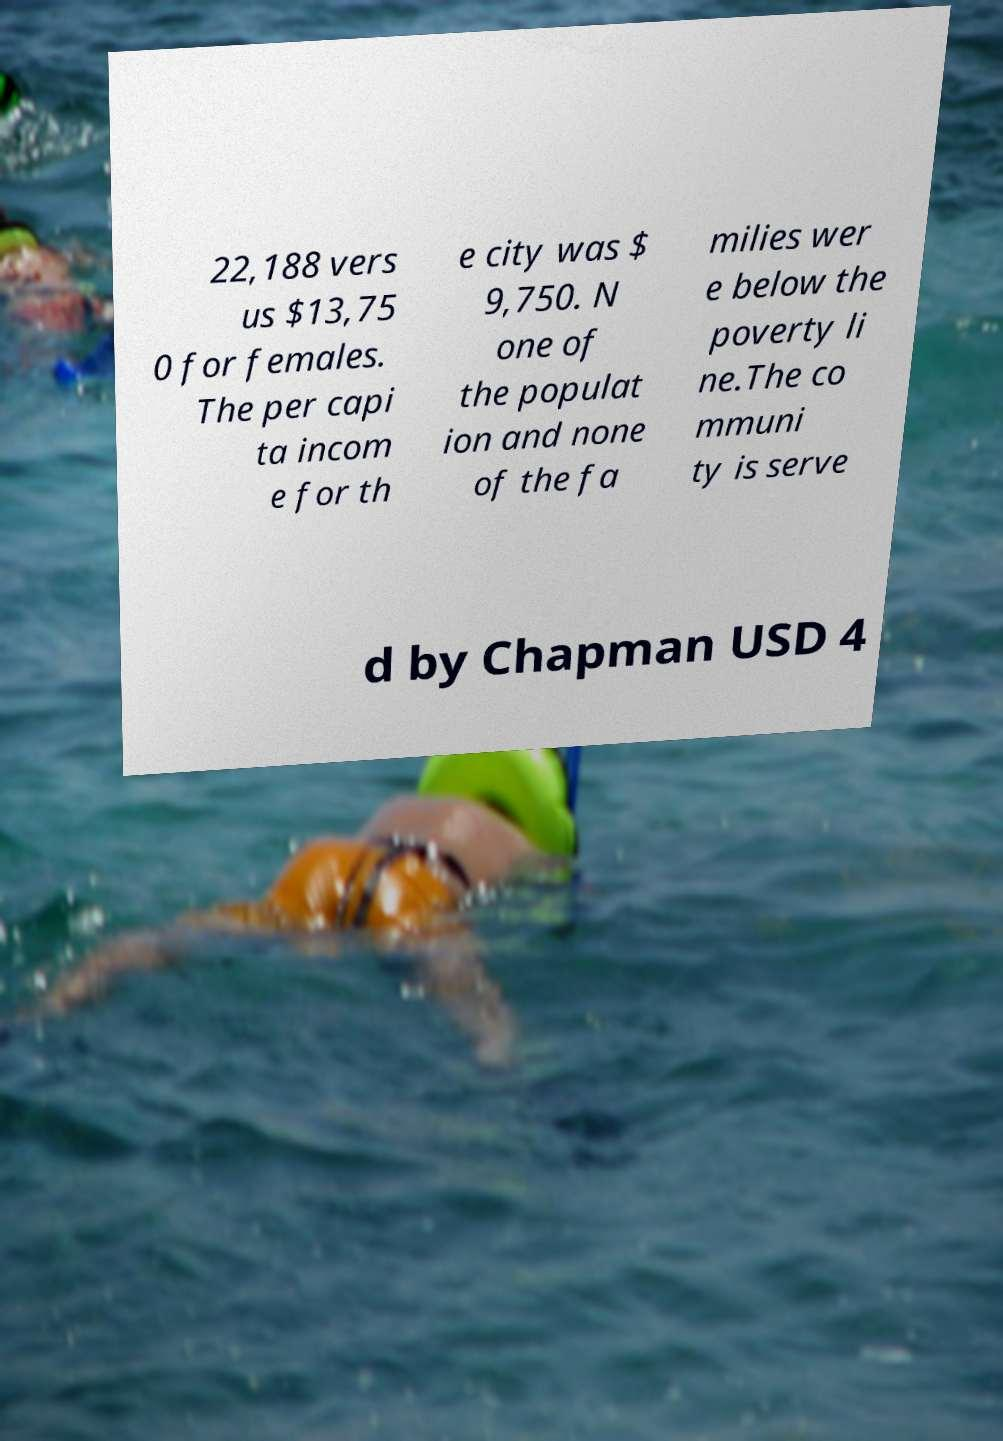Can you accurately transcribe the text from the provided image for me? 22,188 vers us $13,75 0 for females. The per capi ta incom e for th e city was $ 9,750. N one of the populat ion and none of the fa milies wer e below the poverty li ne.The co mmuni ty is serve d by Chapman USD 4 